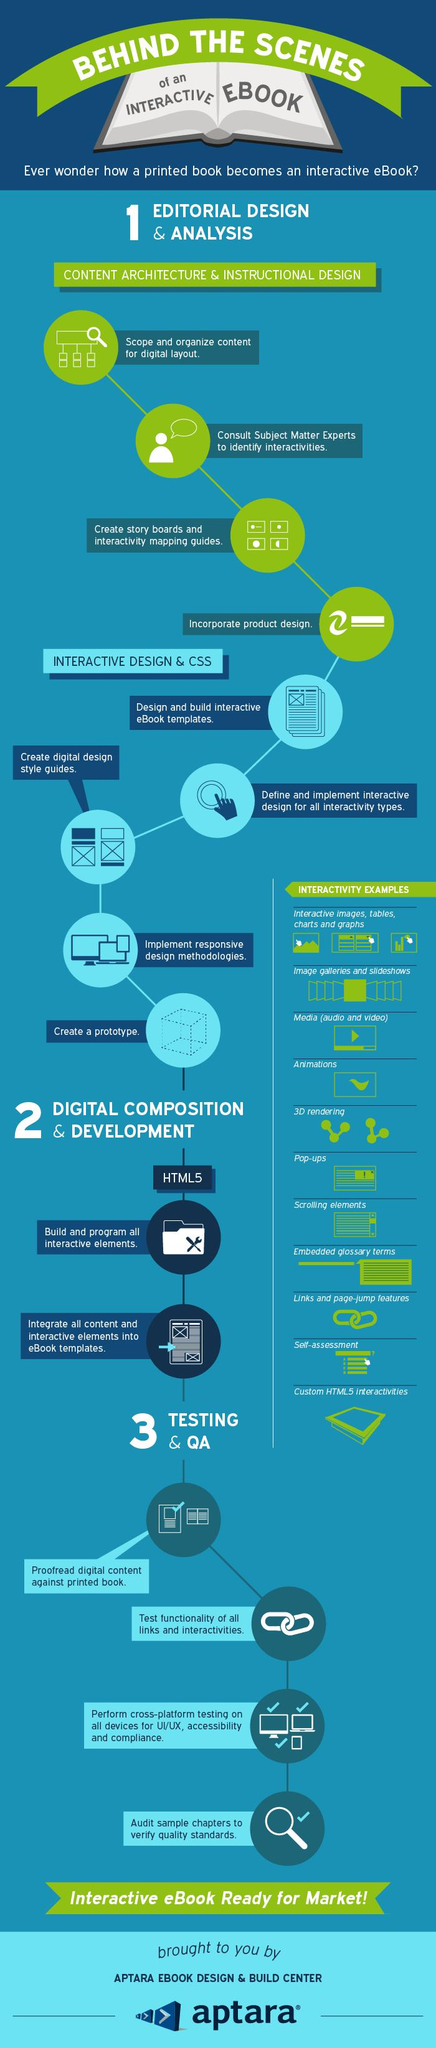Identify some key points in this picture. Animations are the fourth type of interactivity mentioned in the list. The second example of interactivity provided in the list is image galleries and slideshows. The next step after designing an e-book template is to design and implement an interactive design for all interactivity types. After programming all interactive elements, it is necessary to integrate all content and interactive elements into the e-book templates. The final step in interactive design and CSS is to create a prototype. 